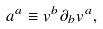<formula> <loc_0><loc_0><loc_500><loc_500>a ^ { a } \equiv v ^ { b } \partial _ { b } v ^ { a } ,</formula> 